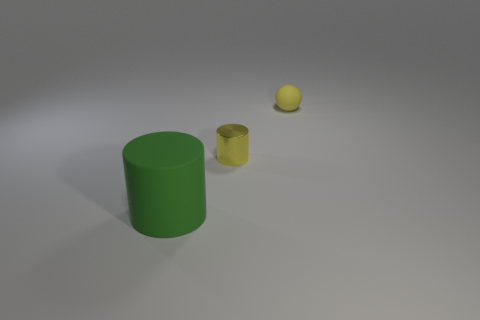Add 2 yellow balls. How many objects exist? 5 Subtract all cylinders. How many objects are left? 1 Add 3 tiny red blocks. How many tiny red blocks exist? 3 Subtract 0 yellow blocks. How many objects are left? 3 Subtract all small yellow cylinders. Subtract all large green rubber cylinders. How many objects are left? 1 Add 1 matte balls. How many matte balls are left? 2 